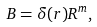<formula> <loc_0><loc_0><loc_500><loc_500>B = \delta ( r ) R ^ { m } ,</formula> 